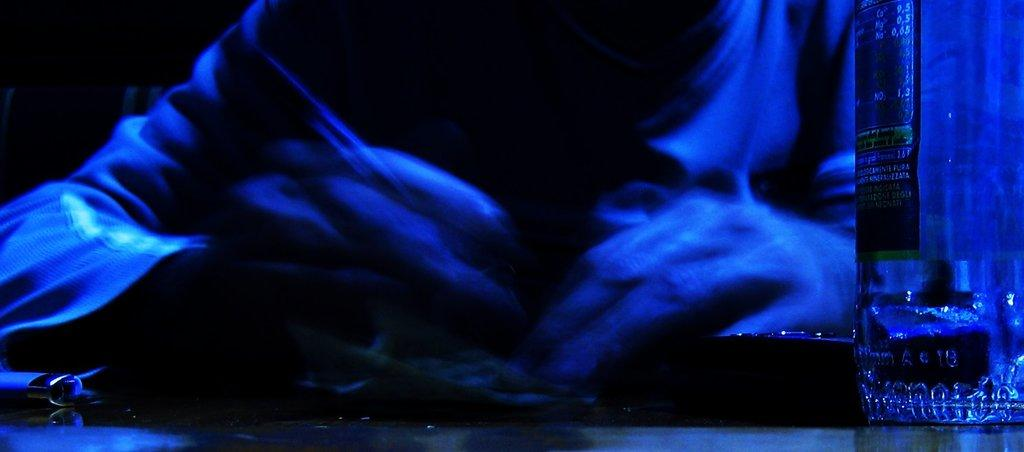What can be seen in the image? There is a person in the image. What is the person holding? The person is holding something. What is in front of the person? There is a bottle in front of the person. What colors are used in the image? The image is in blue and black color. What type of poison is the person holding in the image? There is no poison present in the image. The person is holding something, but it is not specified as poison. 